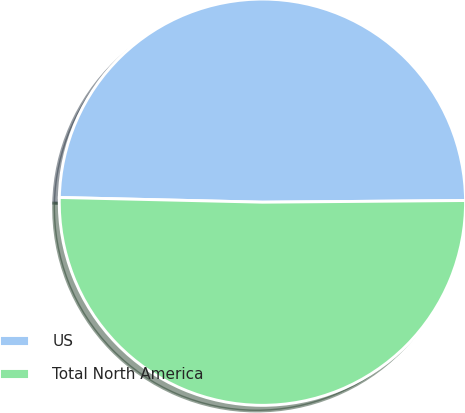Convert chart. <chart><loc_0><loc_0><loc_500><loc_500><pie_chart><fcel>US<fcel>Total North America<nl><fcel>49.5%<fcel>50.5%<nl></chart> 